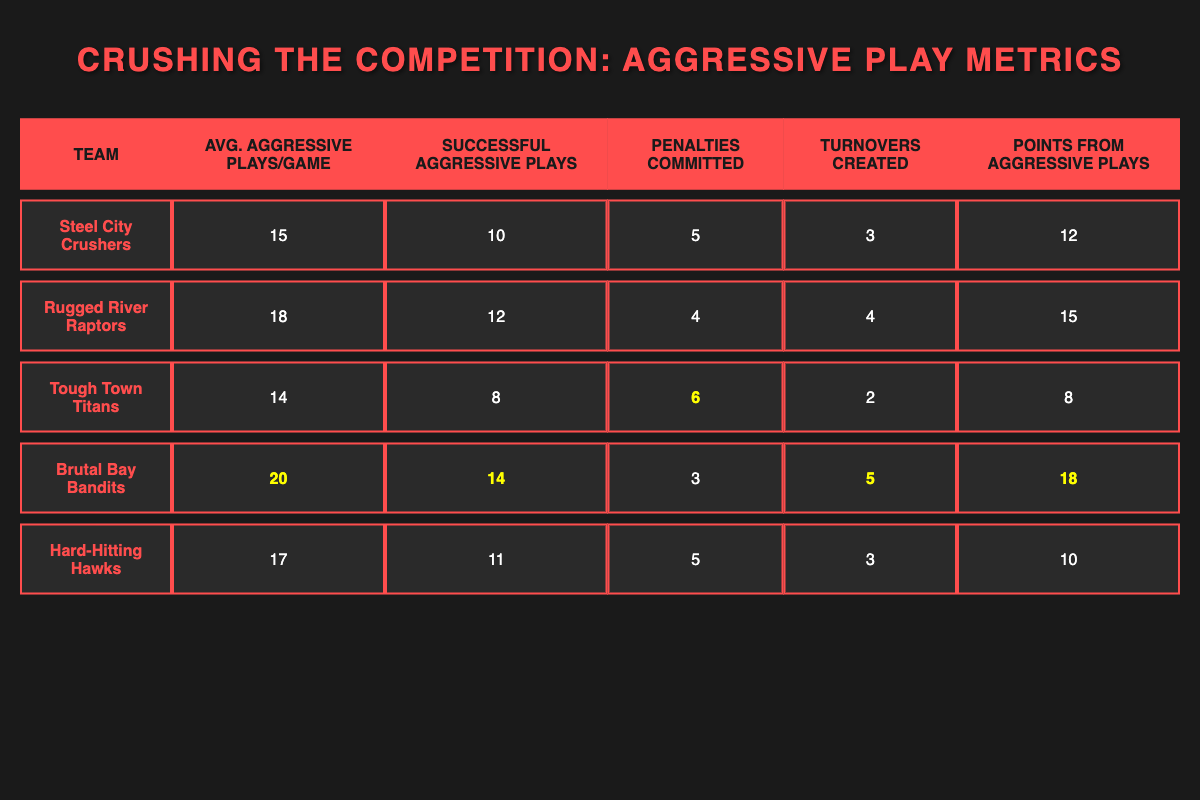What team has the highest average aggressive plays per game? By examining the "Avg. Aggressive Plays/Game" column, we can compare the values presented. The "Brutal Bay Bandits" have an average of 20 aggressive plays per game, which is higher than all other teams listed.
Answer: Brutal Bay Bandits How many penalties did the Tough Town Titans commit? The table shows that the "Tough Town Titans" committed 6 penalties, which can be directly found in the "Penalties Committed" column.
Answer: 6 What is the total number of successful aggressive plays across all teams? We need to sum the "Successful Aggressive Plays" across all teams: 10 (Steel City) + 12 (Rugged River) + 8 (Tough Town) + 14 (Brutal Bay) + 11 (Hard-Hitting) = 55.
Answer: 55 Did the Rugged River Raptors create more turnovers than the Hard-Hitting Hawks? Looking at the "Turnovers Created" column, the Rugged River Raptors created 4 turnovers, while the Hard-Hitting Hawks created 3. Therefore, yes, they created more turnovers.
Answer: Yes What is the average number of points scored from aggressive plays for all teams combined? We first sum the "Points from Aggressive Plays": 12 (Steel City) + 15 (Rugged River) + 8 (Tough Town) + 18 (Brutal Bay) + 10 (Hard-Hitting) = 63. There are 5 teams, so we divide 63 by 5, resulting in an average of 12.6 points.
Answer: 12.6 Which team had the highest penalty ratio (penalties committed divided by average aggressive plays per game)? To find the highest penalty ratio, we calculate the ratio for each team: Steel City (5/15=0.33), Rugged River (4/18=0.22), Tough Town (6/14=0.43), Brutal Bay (3/20=0.15), Hard-Hitting (5/17=0.29). The Tough Town Titans had the highest ratio at approximately 0.43.
Answer: Tough Town Titans Which team scored the least points from aggressive plays? In the "Points from Aggressive Plays" column, we see the scores: 12 (Steel City), 15 (Rugged River), 8 (Tough Town), 18 (Brutal Bay), and 10 (Hard-Hitting). The Tough Town Titans scored the least with 8 points.
Answer: Tough Town Titans What is the difference in average aggressive plays per game between the Brutal Bay Bandits and the Steel City Crushers? The average aggressive plays per game for Brutal Bay Bandits is 20, while for Steel City Crushers it is 15. The difference is 20 - 15 = 5.
Answer: 5 What percentage of aggressive plays by the Hard-Hitting Hawks were successful? For the Hard-Hitting Hawks, the total aggressive plays are 17, and successful plays are 11. The percentage is (11/17) * 100 = 64.71%, which rounds to approximately 65%.
Answer: 65% 